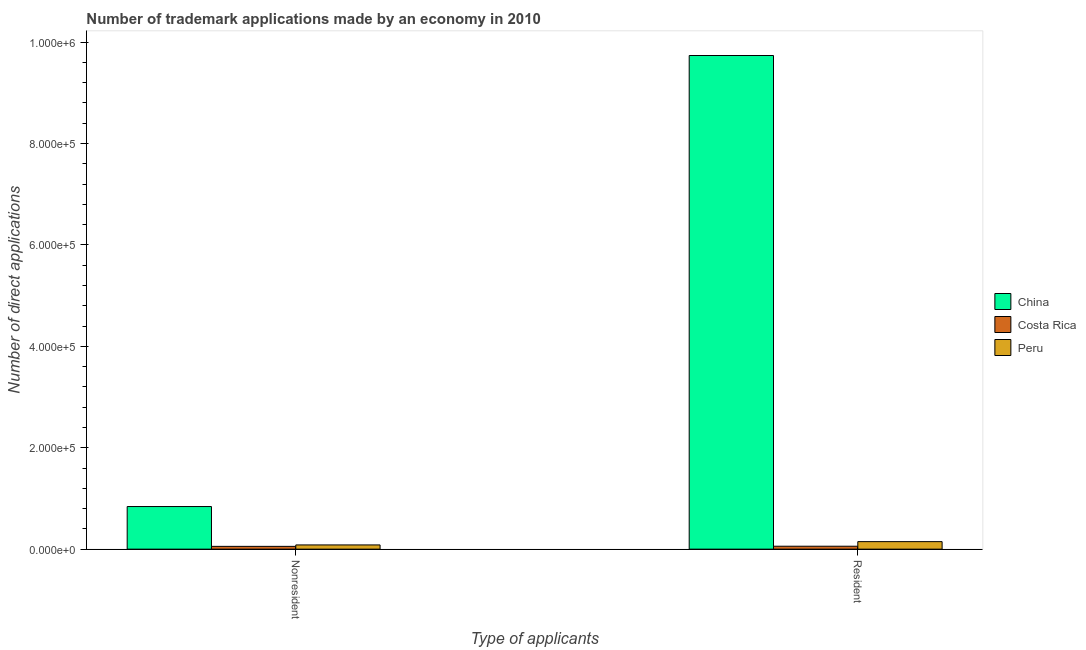How many different coloured bars are there?
Make the answer very short. 3. How many groups of bars are there?
Your answer should be very brief. 2. Are the number of bars per tick equal to the number of legend labels?
Make the answer very short. Yes. Are the number of bars on each tick of the X-axis equal?
Give a very brief answer. Yes. How many bars are there on the 1st tick from the left?
Your response must be concise. 3. How many bars are there on the 2nd tick from the right?
Your answer should be very brief. 3. What is the label of the 1st group of bars from the left?
Ensure brevity in your answer.  Nonresident. What is the number of trademark applications made by residents in China?
Your answer should be compact. 9.73e+05. Across all countries, what is the maximum number of trademark applications made by residents?
Provide a short and direct response. 9.73e+05. Across all countries, what is the minimum number of trademark applications made by non residents?
Offer a very short reply. 5498. What is the total number of trademark applications made by non residents in the graph?
Keep it short and to the point. 9.78e+04. What is the difference between the number of trademark applications made by non residents in Costa Rica and that in Peru?
Keep it short and to the point. -2812. What is the difference between the number of trademark applications made by residents in Peru and the number of trademark applications made by non residents in Costa Rica?
Your answer should be compact. 9312. What is the average number of trademark applications made by non residents per country?
Offer a terse response. 3.26e+04. What is the difference between the number of trademark applications made by non residents and number of trademark applications made by residents in Peru?
Ensure brevity in your answer.  -6500. In how many countries, is the number of trademark applications made by residents greater than 560000 ?
Offer a terse response. 1. What is the ratio of the number of trademark applications made by non residents in Costa Rica to that in China?
Provide a short and direct response. 0.07. In how many countries, is the number of trademark applications made by non residents greater than the average number of trademark applications made by non residents taken over all countries?
Your answer should be very brief. 1. What does the 2nd bar from the right in Resident represents?
Provide a short and direct response. Costa Rica. How many bars are there?
Your response must be concise. 6. Are all the bars in the graph horizontal?
Your response must be concise. No. Are the values on the major ticks of Y-axis written in scientific E-notation?
Your response must be concise. Yes. Where does the legend appear in the graph?
Your answer should be compact. Center right. How many legend labels are there?
Your answer should be compact. 3. How are the legend labels stacked?
Offer a terse response. Vertical. What is the title of the graph?
Ensure brevity in your answer.  Number of trademark applications made by an economy in 2010. Does "Turkey" appear as one of the legend labels in the graph?
Your response must be concise. No. What is the label or title of the X-axis?
Give a very brief answer. Type of applicants. What is the label or title of the Y-axis?
Your answer should be very brief. Number of direct applications. What is the Number of direct applications in China in Nonresident?
Offer a very short reply. 8.40e+04. What is the Number of direct applications in Costa Rica in Nonresident?
Your answer should be very brief. 5498. What is the Number of direct applications in Peru in Nonresident?
Your response must be concise. 8310. What is the Number of direct applications of China in Resident?
Make the answer very short. 9.73e+05. What is the Number of direct applications in Costa Rica in Resident?
Provide a succinct answer. 5767. What is the Number of direct applications in Peru in Resident?
Give a very brief answer. 1.48e+04. Across all Type of applicants, what is the maximum Number of direct applications in China?
Give a very brief answer. 9.73e+05. Across all Type of applicants, what is the maximum Number of direct applications of Costa Rica?
Your answer should be very brief. 5767. Across all Type of applicants, what is the maximum Number of direct applications in Peru?
Provide a short and direct response. 1.48e+04. Across all Type of applicants, what is the minimum Number of direct applications of China?
Give a very brief answer. 8.40e+04. Across all Type of applicants, what is the minimum Number of direct applications in Costa Rica?
Give a very brief answer. 5498. Across all Type of applicants, what is the minimum Number of direct applications of Peru?
Give a very brief answer. 8310. What is the total Number of direct applications of China in the graph?
Your answer should be compact. 1.06e+06. What is the total Number of direct applications in Costa Rica in the graph?
Offer a terse response. 1.13e+04. What is the total Number of direct applications in Peru in the graph?
Offer a very short reply. 2.31e+04. What is the difference between the Number of direct applications of China in Nonresident and that in Resident?
Your response must be concise. -8.89e+05. What is the difference between the Number of direct applications in Costa Rica in Nonresident and that in Resident?
Your answer should be compact. -269. What is the difference between the Number of direct applications of Peru in Nonresident and that in Resident?
Keep it short and to the point. -6500. What is the difference between the Number of direct applications in China in Nonresident and the Number of direct applications in Costa Rica in Resident?
Ensure brevity in your answer.  7.83e+04. What is the difference between the Number of direct applications in China in Nonresident and the Number of direct applications in Peru in Resident?
Your response must be concise. 6.92e+04. What is the difference between the Number of direct applications in Costa Rica in Nonresident and the Number of direct applications in Peru in Resident?
Provide a short and direct response. -9312. What is the average Number of direct applications of China per Type of applicants?
Keep it short and to the point. 5.29e+05. What is the average Number of direct applications in Costa Rica per Type of applicants?
Provide a succinct answer. 5632.5. What is the average Number of direct applications of Peru per Type of applicants?
Provide a short and direct response. 1.16e+04. What is the difference between the Number of direct applications in China and Number of direct applications in Costa Rica in Nonresident?
Your answer should be very brief. 7.85e+04. What is the difference between the Number of direct applications of China and Number of direct applications of Peru in Nonresident?
Give a very brief answer. 7.57e+04. What is the difference between the Number of direct applications in Costa Rica and Number of direct applications in Peru in Nonresident?
Offer a terse response. -2812. What is the difference between the Number of direct applications in China and Number of direct applications in Costa Rica in Resident?
Ensure brevity in your answer.  9.68e+05. What is the difference between the Number of direct applications in China and Number of direct applications in Peru in Resident?
Your answer should be compact. 9.59e+05. What is the difference between the Number of direct applications in Costa Rica and Number of direct applications in Peru in Resident?
Ensure brevity in your answer.  -9043. What is the ratio of the Number of direct applications in China in Nonresident to that in Resident?
Give a very brief answer. 0.09. What is the ratio of the Number of direct applications in Costa Rica in Nonresident to that in Resident?
Offer a very short reply. 0.95. What is the ratio of the Number of direct applications in Peru in Nonresident to that in Resident?
Provide a succinct answer. 0.56. What is the difference between the highest and the second highest Number of direct applications of China?
Keep it short and to the point. 8.89e+05. What is the difference between the highest and the second highest Number of direct applications in Costa Rica?
Offer a very short reply. 269. What is the difference between the highest and the second highest Number of direct applications of Peru?
Keep it short and to the point. 6500. What is the difference between the highest and the lowest Number of direct applications in China?
Offer a very short reply. 8.89e+05. What is the difference between the highest and the lowest Number of direct applications in Costa Rica?
Offer a terse response. 269. What is the difference between the highest and the lowest Number of direct applications of Peru?
Your answer should be very brief. 6500. 